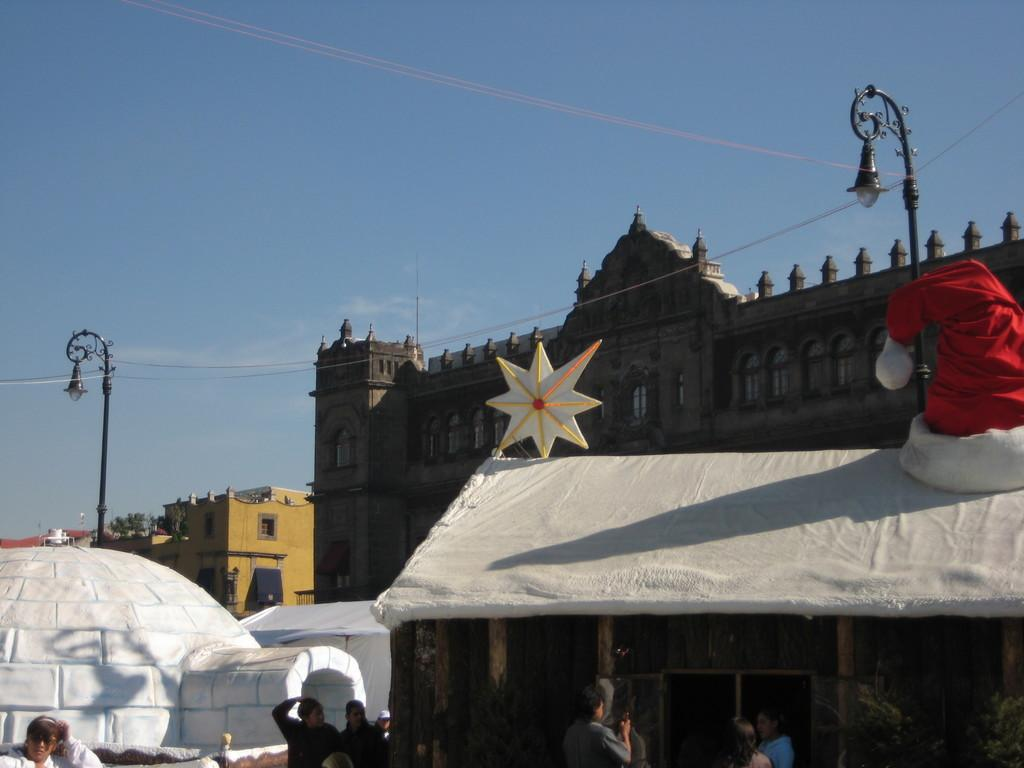What type of view is shown in the image? The image is an outside view. Can you describe the people at the bottom of the image? There are people at the bottom of the image, but their specific actions or appearances cannot be determined from the provided facts. What can be seen in the background of the image? There are buildings and two light poles in the background of the image. What is visible at the top of the image? The sky is visible at the top of the image. What type of cloth is draped over the north pole in the image? There is no cloth or north pole present in the image. 